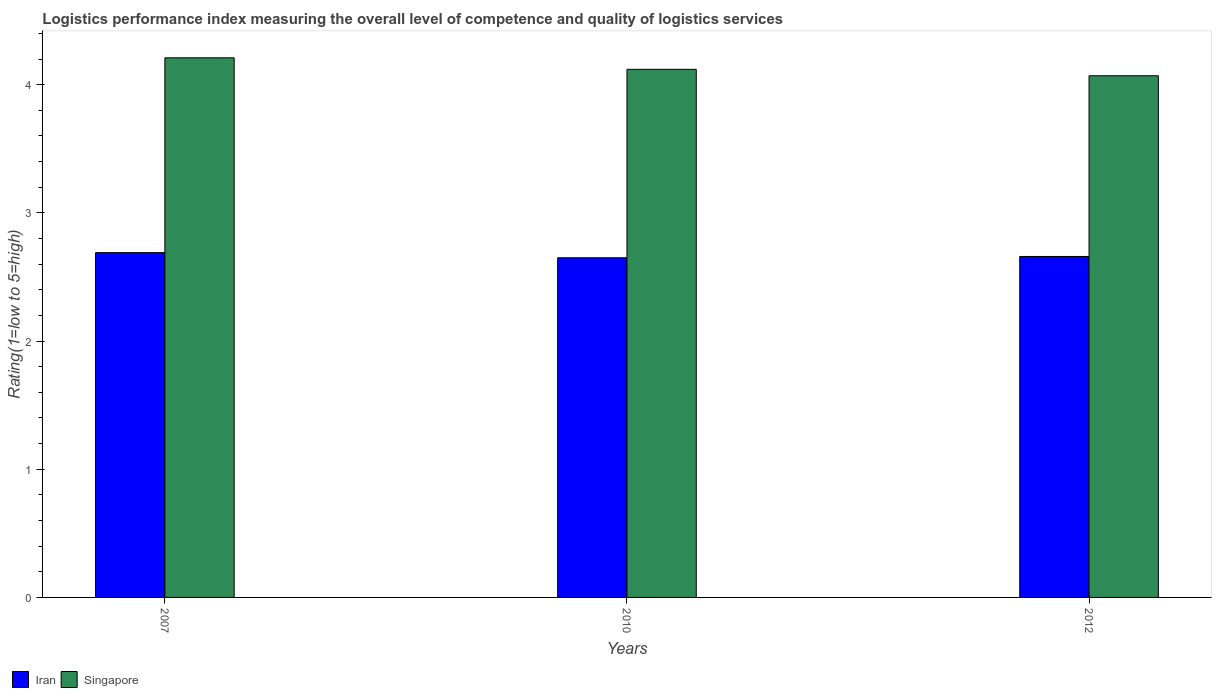How many different coloured bars are there?
Make the answer very short. 2. How many groups of bars are there?
Give a very brief answer. 3. Are the number of bars per tick equal to the number of legend labels?
Offer a terse response. Yes. Are the number of bars on each tick of the X-axis equal?
Make the answer very short. Yes. How many bars are there on the 2nd tick from the left?
Your response must be concise. 2. How many bars are there on the 3rd tick from the right?
Give a very brief answer. 2. What is the Logistic performance index in Iran in 2010?
Keep it short and to the point. 2.65. Across all years, what is the maximum Logistic performance index in Iran?
Provide a short and direct response. 2.69. Across all years, what is the minimum Logistic performance index in Iran?
Your answer should be very brief. 2.65. What is the total Logistic performance index in Iran in the graph?
Provide a short and direct response. 8. What is the difference between the Logistic performance index in Singapore in 2007 and that in 2010?
Provide a short and direct response. 0.09. What is the difference between the Logistic performance index in Singapore in 2010 and the Logistic performance index in Iran in 2012?
Offer a very short reply. 1.46. What is the average Logistic performance index in Iran per year?
Offer a terse response. 2.67. In the year 2012, what is the difference between the Logistic performance index in Singapore and Logistic performance index in Iran?
Offer a very short reply. 1.41. What is the ratio of the Logistic performance index in Iran in 2010 to that in 2012?
Keep it short and to the point. 1. Is the difference between the Logistic performance index in Singapore in 2010 and 2012 greater than the difference between the Logistic performance index in Iran in 2010 and 2012?
Your answer should be very brief. Yes. What is the difference between the highest and the second highest Logistic performance index in Singapore?
Ensure brevity in your answer.  0.09. What is the difference between the highest and the lowest Logistic performance index in Singapore?
Ensure brevity in your answer.  0.14. In how many years, is the Logistic performance index in Singapore greater than the average Logistic performance index in Singapore taken over all years?
Offer a very short reply. 1. Is the sum of the Logistic performance index in Iran in 2010 and 2012 greater than the maximum Logistic performance index in Singapore across all years?
Provide a short and direct response. Yes. What does the 2nd bar from the left in 2007 represents?
Your answer should be compact. Singapore. What does the 2nd bar from the right in 2012 represents?
Keep it short and to the point. Iran. How many years are there in the graph?
Your answer should be compact. 3. What is the difference between two consecutive major ticks on the Y-axis?
Provide a succinct answer. 1. Does the graph contain any zero values?
Offer a very short reply. No. Does the graph contain grids?
Provide a succinct answer. No. How are the legend labels stacked?
Your response must be concise. Horizontal. What is the title of the graph?
Keep it short and to the point. Logistics performance index measuring the overall level of competence and quality of logistics services. Does "Central Europe" appear as one of the legend labels in the graph?
Offer a terse response. No. What is the label or title of the X-axis?
Make the answer very short. Years. What is the label or title of the Y-axis?
Your response must be concise. Rating(1=low to 5=high). What is the Rating(1=low to 5=high) of Iran in 2007?
Make the answer very short. 2.69. What is the Rating(1=low to 5=high) in Singapore in 2007?
Make the answer very short. 4.21. What is the Rating(1=low to 5=high) of Iran in 2010?
Keep it short and to the point. 2.65. What is the Rating(1=low to 5=high) of Singapore in 2010?
Give a very brief answer. 4.12. What is the Rating(1=low to 5=high) in Iran in 2012?
Offer a terse response. 2.66. What is the Rating(1=low to 5=high) in Singapore in 2012?
Make the answer very short. 4.07. Across all years, what is the maximum Rating(1=low to 5=high) of Iran?
Keep it short and to the point. 2.69. Across all years, what is the maximum Rating(1=low to 5=high) in Singapore?
Offer a very short reply. 4.21. Across all years, what is the minimum Rating(1=low to 5=high) in Iran?
Make the answer very short. 2.65. Across all years, what is the minimum Rating(1=low to 5=high) in Singapore?
Offer a very short reply. 4.07. What is the total Rating(1=low to 5=high) of Singapore in the graph?
Give a very brief answer. 12.4. What is the difference between the Rating(1=low to 5=high) in Singapore in 2007 and that in 2010?
Ensure brevity in your answer.  0.09. What is the difference between the Rating(1=low to 5=high) in Singapore in 2007 and that in 2012?
Your response must be concise. 0.14. What is the difference between the Rating(1=low to 5=high) of Iran in 2010 and that in 2012?
Your response must be concise. -0.01. What is the difference between the Rating(1=low to 5=high) of Singapore in 2010 and that in 2012?
Make the answer very short. 0.05. What is the difference between the Rating(1=low to 5=high) of Iran in 2007 and the Rating(1=low to 5=high) of Singapore in 2010?
Keep it short and to the point. -1.43. What is the difference between the Rating(1=low to 5=high) of Iran in 2007 and the Rating(1=low to 5=high) of Singapore in 2012?
Provide a short and direct response. -1.38. What is the difference between the Rating(1=low to 5=high) of Iran in 2010 and the Rating(1=low to 5=high) of Singapore in 2012?
Offer a terse response. -1.42. What is the average Rating(1=low to 5=high) in Iran per year?
Your answer should be compact. 2.67. What is the average Rating(1=low to 5=high) of Singapore per year?
Keep it short and to the point. 4.13. In the year 2007, what is the difference between the Rating(1=low to 5=high) in Iran and Rating(1=low to 5=high) in Singapore?
Make the answer very short. -1.52. In the year 2010, what is the difference between the Rating(1=low to 5=high) in Iran and Rating(1=low to 5=high) in Singapore?
Your response must be concise. -1.47. In the year 2012, what is the difference between the Rating(1=low to 5=high) of Iran and Rating(1=low to 5=high) of Singapore?
Offer a very short reply. -1.41. What is the ratio of the Rating(1=low to 5=high) in Iran in 2007 to that in 2010?
Ensure brevity in your answer.  1.02. What is the ratio of the Rating(1=low to 5=high) of Singapore in 2007 to that in 2010?
Provide a short and direct response. 1.02. What is the ratio of the Rating(1=low to 5=high) of Iran in 2007 to that in 2012?
Ensure brevity in your answer.  1.01. What is the ratio of the Rating(1=low to 5=high) of Singapore in 2007 to that in 2012?
Your answer should be compact. 1.03. What is the ratio of the Rating(1=low to 5=high) in Iran in 2010 to that in 2012?
Make the answer very short. 1. What is the ratio of the Rating(1=low to 5=high) in Singapore in 2010 to that in 2012?
Make the answer very short. 1.01. What is the difference between the highest and the second highest Rating(1=low to 5=high) in Iran?
Provide a short and direct response. 0.03. What is the difference between the highest and the second highest Rating(1=low to 5=high) of Singapore?
Offer a terse response. 0.09. What is the difference between the highest and the lowest Rating(1=low to 5=high) of Singapore?
Give a very brief answer. 0.14. 